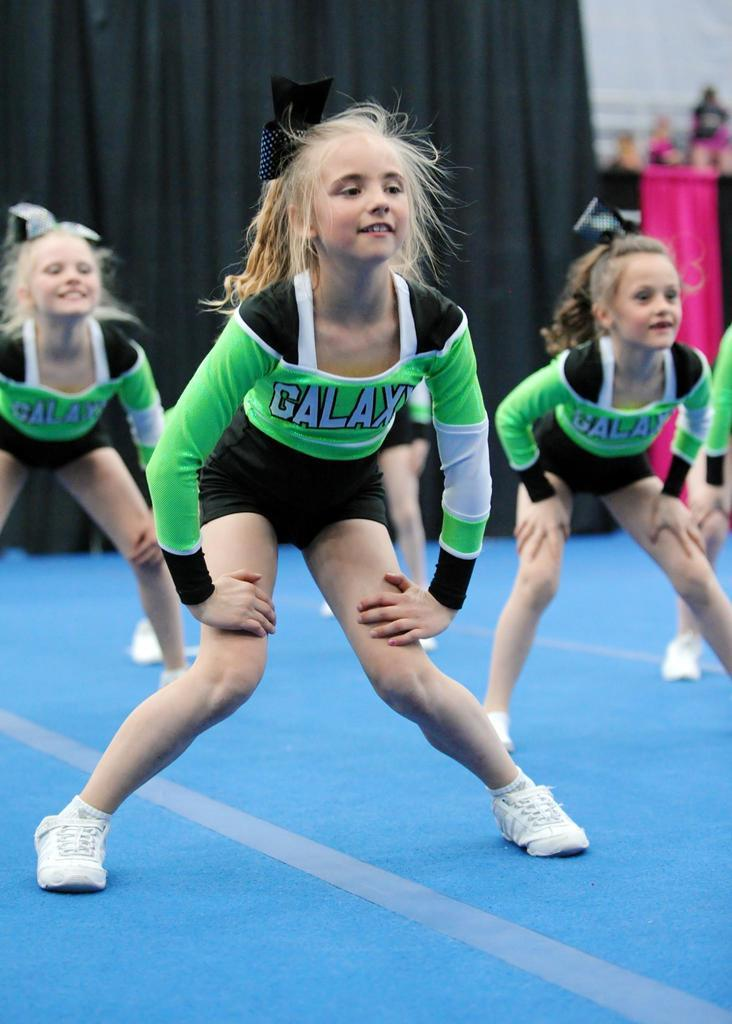<image>
Offer a succinct explanation of the picture presented. Girls are in a cheer leading competition and the their team name is the Galaxy. 